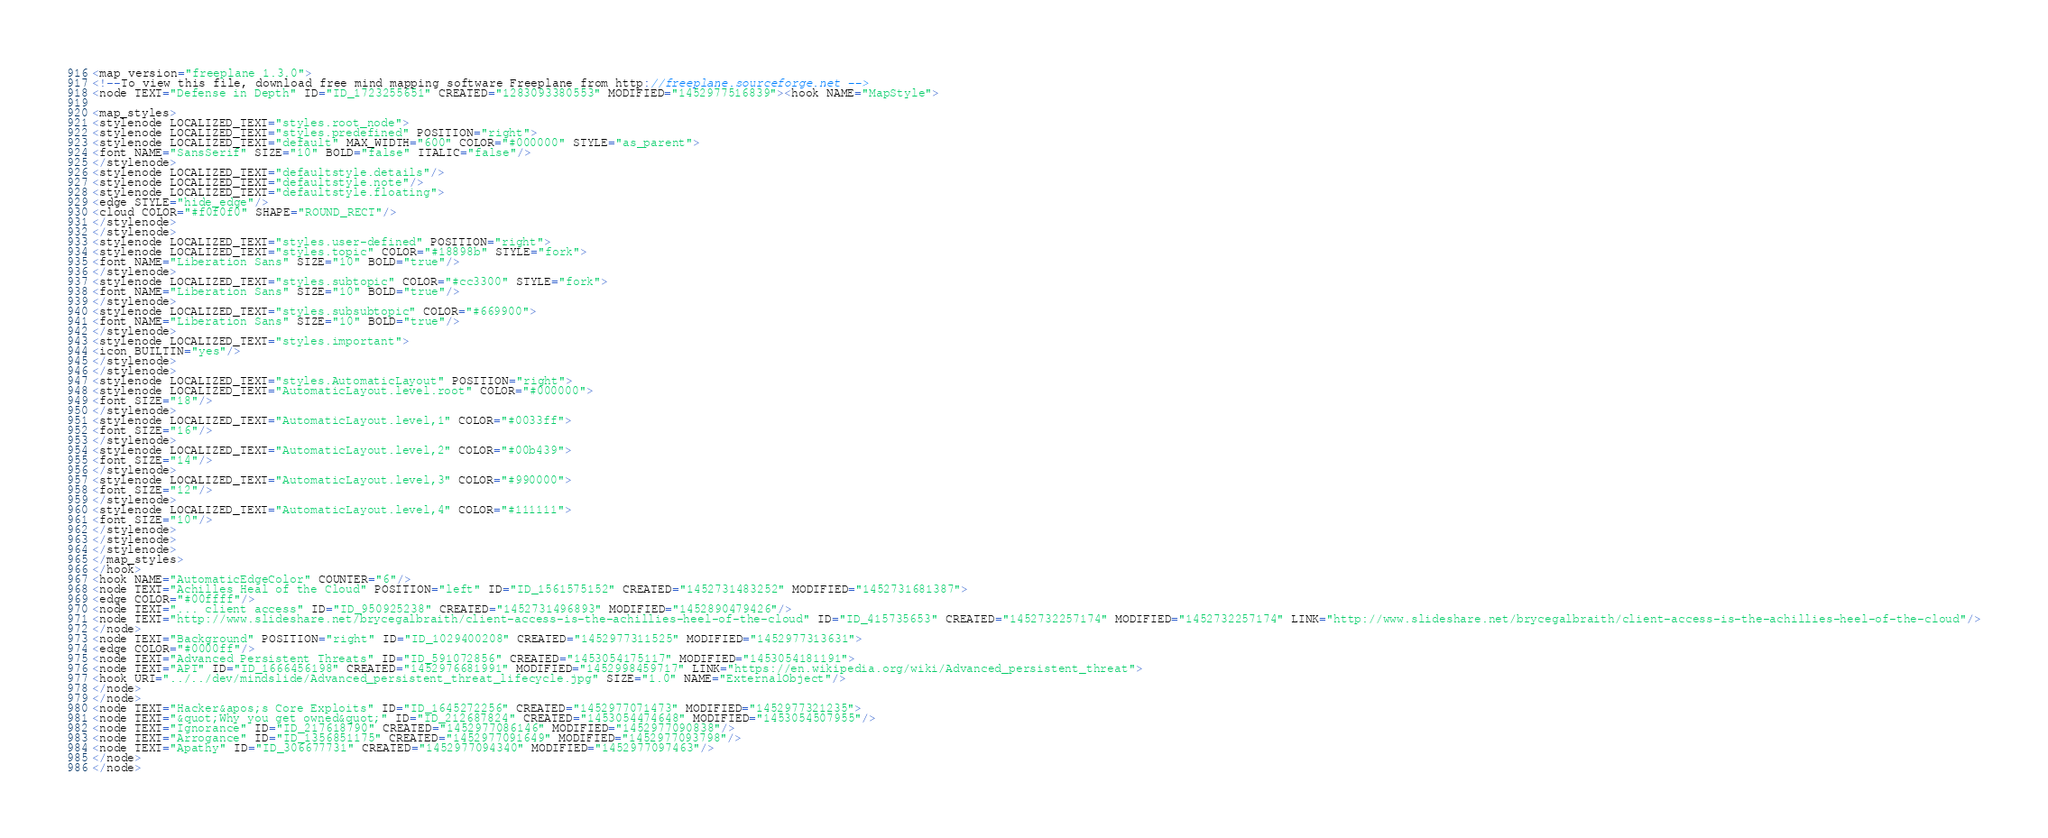<code> <loc_0><loc_0><loc_500><loc_500><_ObjectiveC_><map version="freeplane 1.3.0">
<!--To view this file, download free mind mapping software Freeplane from http://freeplane.sourceforge.net -->
<node TEXT="Defense in Depth" ID="ID_1723255651" CREATED="1283093380553" MODIFIED="1452977516839"><hook NAME="MapStyle">

<map_styles>
<stylenode LOCALIZED_TEXT="styles.root_node">
<stylenode LOCALIZED_TEXT="styles.predefined" POSITION="right">
<stylenode LOCALIZED_TEXT="default" MAX_WIDTH="600" COLOR="#000000" STYLE="as_parent">
<font NAME="SansSerif" SIZE="10" BOLD="false" ITALIC="false"/>
</stylenode>
<stylenode LOCALIZED_TEXT="defaultstyle.details"/>
<stylenode LOCALIZED_TEXT="defaultstyle.note"/>
<stylenode LOCALIZED_TEXT="defaultstyle.floating">
<edge STYLE="hide_edge"/>
<cloud COLOR="#f0f0f0" SHAPE="ROUND_RECT"/>
</stylenode>
</stylenode>
<stylenode LOCALIZED_TEXT="styles.user-defined" POSITION="right">
<stylenode LOCALIZED_TEXT="styles.topic" COLOR="#18898b" STYLE="fork">
<font NAME="Liberation Sans" SIZE="10" BOLD="true"/>
</stylenode>
<stylenode LOCALIZED_TEXT="styles.subtopic" COLOR="#cc3300" STYLE="fork">
<font NAME="Liberation Sans" SIZE="10" BOLD="true"/>
</stylenode>
<stylenode LOCALIZED_TEXT="styles.subsubtopic" COLOR="#669900">
<font NAME="Liberation Sans" SIZE="10" BOLD="true"/>
</stylenode>
<stylenode LOCALIZED_TEXT="styles.important">
<icon BUILTIN="yes"/>
</stylenode>
</stylenode>
<stylenode LOCALIZED_TEXT="styles.AutomaticLayout" POSITION="right">
<stylenode LOCALIZED_TEXT="AutomaticLayout.level.root" COLOR="#000000">
<font SIZE="18"/>
</stylenode>
<stylenode LOCALIZED_TEXT="AutomaticLayout.level,1" COLOR="#0033ff">
<font SIZE="16"/>
</stylenode>
<stylenode LOCALIZED_TEXT="AutomaticLayout.level,2" COLOR="#00b439">
<font SIZE="14"/>
</stylenode>
<stylenode LOCALIZED_TEXT="AutomaticLayout.level,3" COLOR="#990000">
<font SIZE="12"/>
</stylenode>
<stylenode LOCALIZED_TEXT="AutomaticLayout.level,4" COLOR="#111111">
<font SIZE="10"/>
</stylenode>
</stylenode>
</stylenode>
</map_styles>
</hook>
<hook NAME="AutomaticEdgeColor" COUNTER="6"/>
<node TEXT="Achilles Heal of the Cloud" POSITION="left" ID="ID_1561575152" CREATED="1452731483252" MODIFIED="1452731681387">
<edge COLOR="#00ffff"/>
<node TEXT="... client access" ID="ID_950925238" CREATED="1452731496893" MODIFIED="1452890479426"/>
<node TEXT="http://www.slideshare.net/brycegalbraith/client-access-is-the-achillies-heel-of-the-cloud" ID="ID_415735653" CREATED="1452732257174" MODIFIED="1452732257174" LINK="http://www.slideshare.net/brycegalbraith/client-access-is-the-achillies-heel-of-the-cloud"/>
</node>
<node TEXT="Background" POSITION="right" ID="ID_1029400208" CREATED="1452977311525" MODIFIED="1452977313631">
<edge COLOR="#0000ff"/>
<node TEXT="Advanced Persistent Threats" ID="ID_591072856" CREATED="1453054175117" MODIFIED="1453054181191">
<node TEXT="APT" ID="ID_1666456198" CREATED="1452976681991" MODIFIED="1452998459717" LINK="https://en.wikipedia.org/wiki/Advanced_persistent_threat">
<hook URI="../../dev/mindslide/Advanced_persistent_threat_lifecycle.jpg" SIZE="1.0" NAME="ExternalObject"/>
</node>
</node>
<node TEXT="Hacker&apos;s Core Exploits" ID="ID_1645272256" CREATED="1452977071473" MODIFIED="1452977321235">
<node TEXT="&quot;Why you get owned&quot;" ID="ID_212687824" CREATED="1453054474648" MODIFIED="1453054507955"/>
<node TEXT="Ignorance" ID="ID_217618790" CREATED="1452977086146" MODIFIED="1452977090838"/>
<node TEXT="Arrogance" ID="ID_1356851175" CREATED="1452977091649" MODIFIED="1452977093798"/>
<node TEXT="Apathy" ID="ID_306677731" CREATED="1452977094340" MODIFIED="1452977097463"/>
</node>
</node></code> 